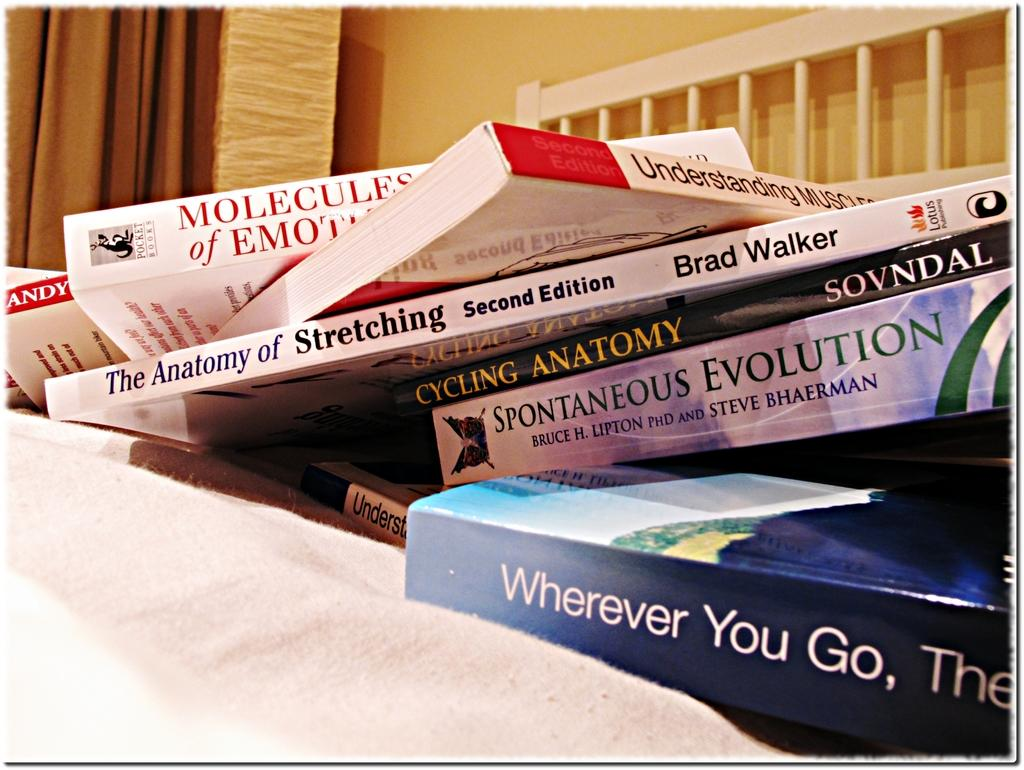<image>
Share a concise interpretation of the image provided. A pile of books is on a bed including one called Cycling Anatomy. 